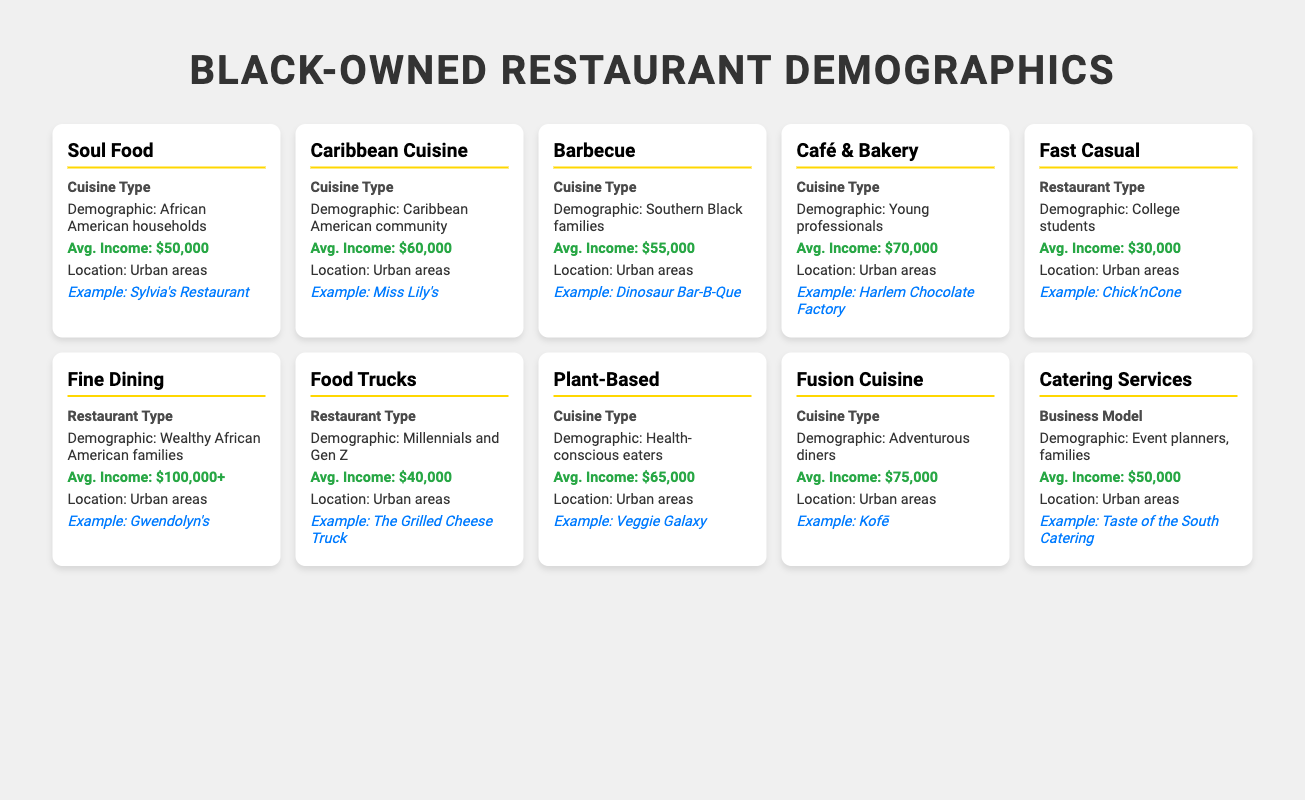What is the average income of the Soul Food demographic? The average income for Soul Food is listed as $50,000, directly stating the value in the table.
Answer: $50,000 Which cuisine type has the highest average income demographic? The Fine Dining cuisine type shows an average income of $100,000+, which is higher than all other cuisine types listed.
Answer: Fine Dining Are there more examples of restaurants in the Café & Bakery category or the Barbecue category? The table shows one example restaurant for both the Café & Bakery and Barbecue categories (Harlem Chocolate Factory and Dinosaur Bar-B-Que respectively), so they are equal in number.
Answer: Yes, they have the same number of examples What is the total average income of the demographics for Fast Casual and Food Trucks combined? Fast Casual has an average income of $30,000 and Food Trucks have $40,000. The total is $30,000 + $40,000 = $70,000.
Answer: $70,000 Do Health-conscious eaters prefer Plant-Based cuisine? Yes, the table lists Plant-Based as catering to Health-conscious eaters, confirming a preference in this demographic.
Answer: Yes Which demographic has the lowest average income among all listed? The Fast Casual demographic of college students has the lowest average income, which is $30,000, compared to all other demographic average incomes in the table.
Answer: College students If we compare Fast Casual and Fine Dining, what is the income difference? Fine Dining has an average income of $100,000+ and Fast Casual has $30,000. The difference is $100,000 - $30,000 = $70,000.
Answer: $70,000 Which cuisine type targets adventurous diners? The Fusion Cuisine is directly associated with adventurous diners as per the table description.
Answer: Fusion Cuisine What is the average income of the Catering Services demographic? Catering Services have an average income of $50,000, as stated in the table for that category.
Answer: $50,000 